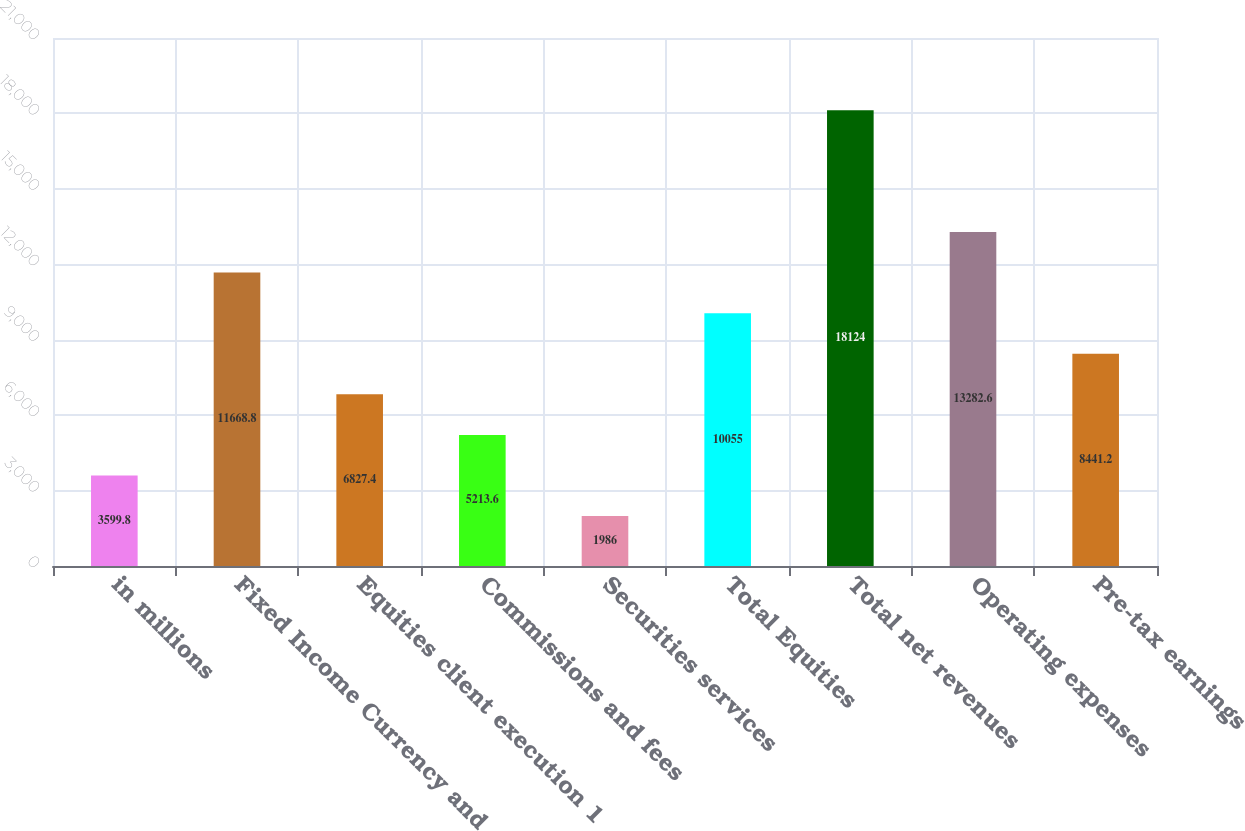Convert chart. <chart><loc_0><loc_0><loc_500><loc_500><bar_chart><fcel>in millions<fcel>Fixed Income Currency and<fcel>Equities client execution 1<fcel>Commissions and fees<fcel>Securities services<fcel>Total Equities<fcel>Total net revenues<fcel>Operating expenses<fcel>Pre-tax earnings<nl><fcel>3599.8<fcel>11668.8<fcel>6827.4<fcel>5213.6<fcel>1986<fcel>10055<fcel>18124<fcel>13282.6<fcel>8441.2<nl></chart> 